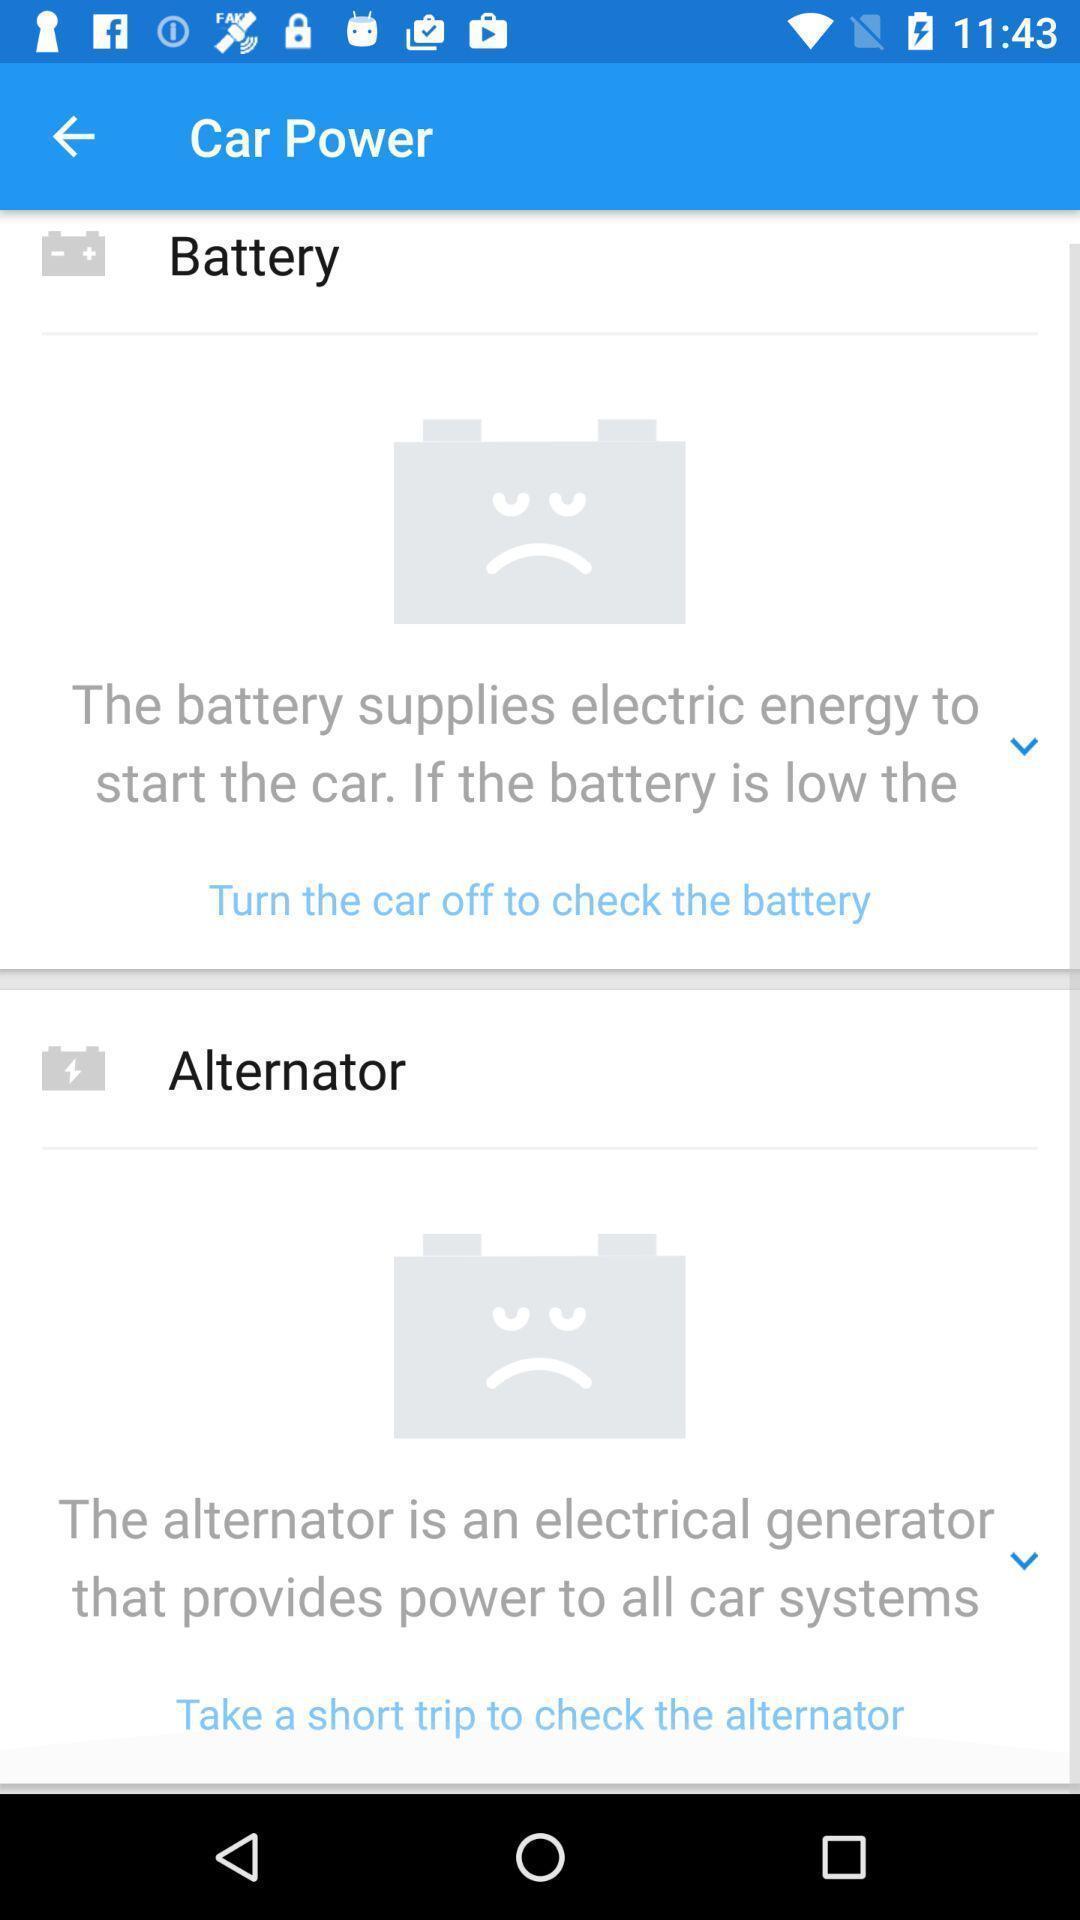Summarize the information in this screenshot. Screen shows car power details. 